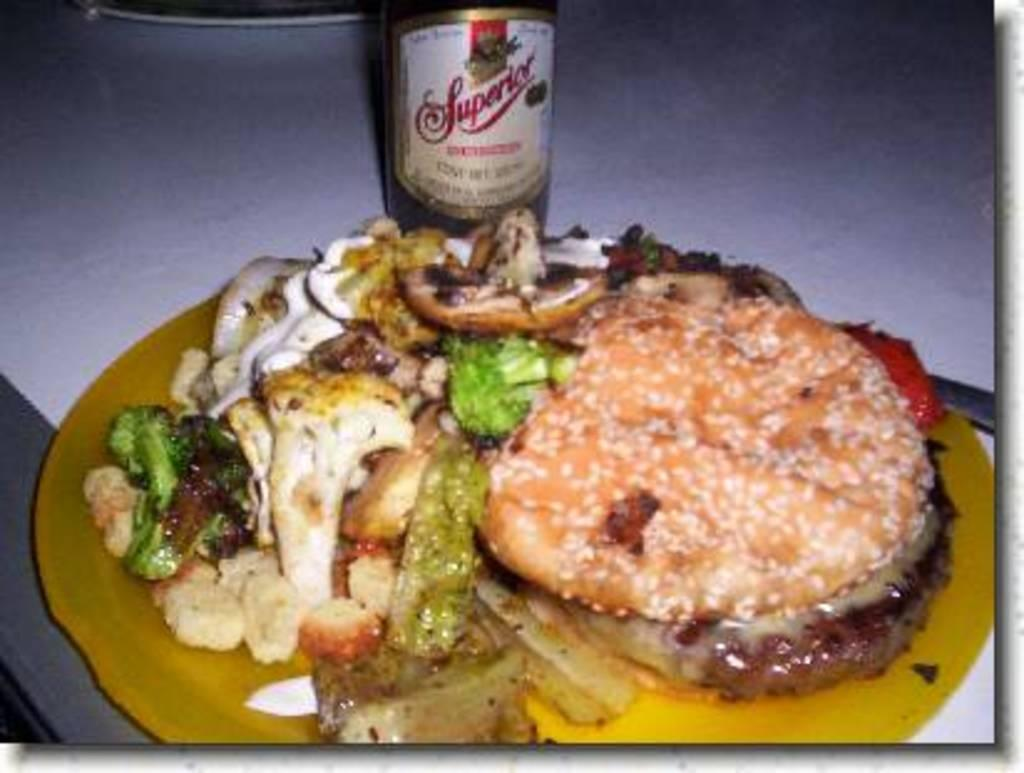What is on the plate that is visible in the image? There is a plate with food in the image. What color is the plate? The plate is yellow. How would you describe the appearance of the food on the plate? The food is colorful. What is located next to the plate in the image? There is a bottle next to the plate. What is the color of the surface on which the plate and bottle are placed? The plate and bottle are on a white surface. What is the price of the zipper on the plate in the image? There is no zipper present in the image, so it is not possible to determine its price. 